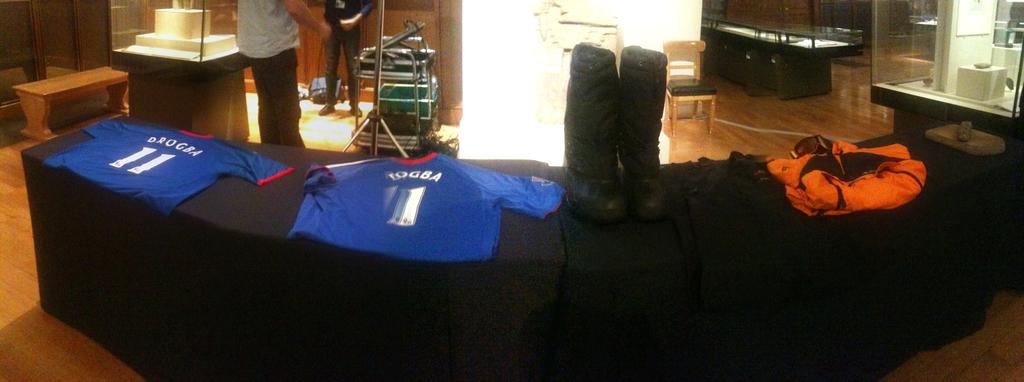What number is does both jerseys have in common?
Your answer should be very brief. 1. What name is on jersey 11?
Provide a short and direct response. Drogba. 